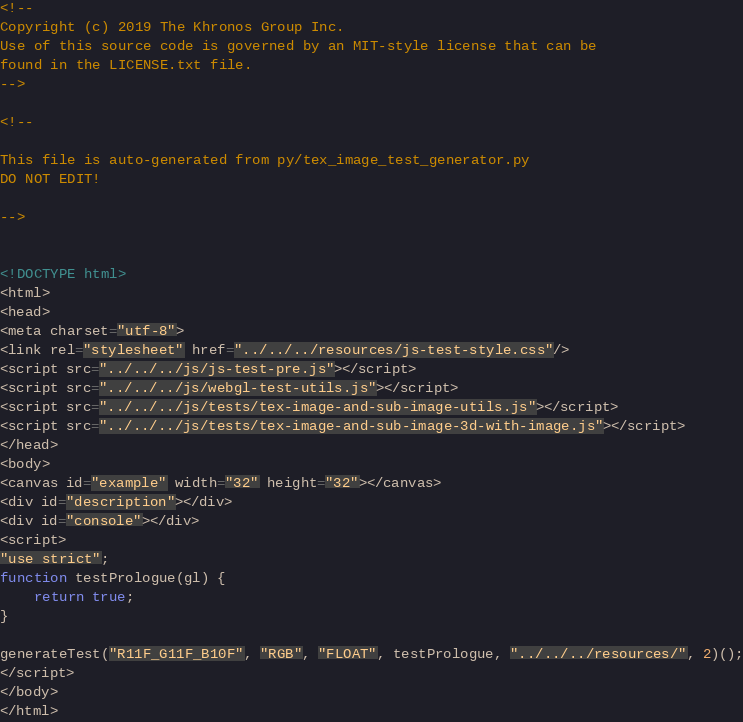Convert code to text. <code><loc_0><loc_0><loc_500><loc_500><_HTML_><!--
Copyright (c) 2019 The Khronos Group Inc.
Use of this source code is governed by an MIT-style license that can be
found in the LICENSE.txt file.
-->

<!--

This file is auto-generated from py/tex_image_test_generator.py
DO NOT EDIT!

-->


<!DOCTYPE html>
<html>
<head>
<meta charset="utf-8">
<link rel="stylesheet" href="../../../resources/js-test-style.css"/>
<script src="../../../js/js-test-pre.js"></script>
<script src="../../../js/webgl-test-utils.js"></script>
<script src="../../../js/tests/tex-image-and-sub-image-utils.js"></script>
<script src="../../../js/tests/tex-image-and-sub-image-3d-with-image.js"></script>
</head>
<body>
<canvas id="example" width="32" height="32"></canvas>
<div id="description"></div>
<div id="console"></div>
<script>
"use strict";
function testPrologue(gl) {
    return true;
}

generateTest("R11F_G11F_B10F", "RGB", "FLOAT", testPrologue, "../../../resources/", 2)();
</script>
</body>
</html>
</code> 